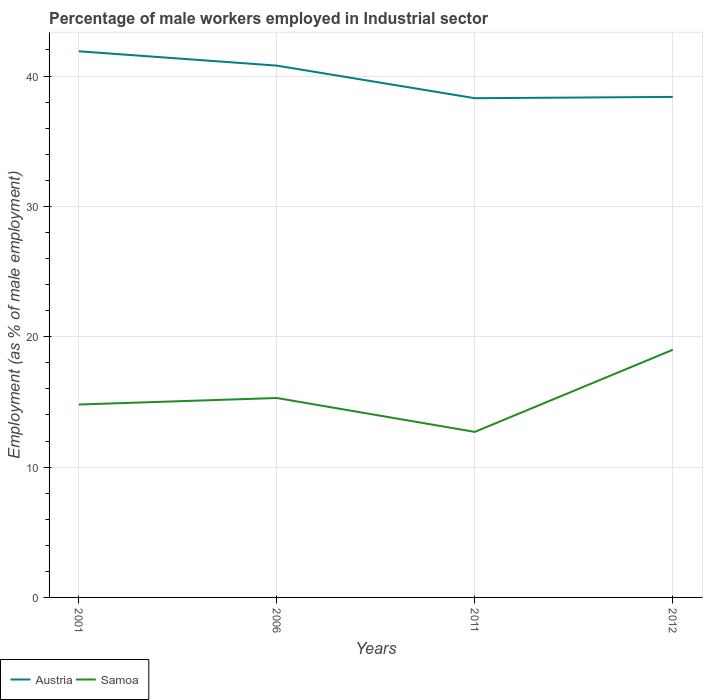Does the line corresponding to Austria intersect with the line corresponding to Samoa?
Give a very brief answer. No. Across all years, what is the maximum percentage of male workers employed in Industrial sector in Austria?
Your answer should be compact. 38.3. What is the total percentage of male workers employed in Industrial sector in Austria in the graph?
Offer a very short reply. 1.1. What is the difference between the highest and the second highest percentage of male workers employed in Industrial sector in Austria?
Make the answer very short. 3.6. What is the difference between the highest and the lowest percentage of male workers employed in Industrial sector in Samoa?
Your answer should be compact. 1. How many years are there in the graph?
Give a very brief answer. 4. What is the difference between two consecutive major ticks on the Y-axis?
Your answer should be compact. 10. Are the values on the major ticks of Y-axis written in scientific E-notation?
Your response must be concise. No. Does the graph contain grids?
Your answer should be compact. Yes. Where does the legend appear in the graph?
Offer a terse response. Bottom left. What is the title of the graph?
Your answer should be very brief. Percentage of male workers employed in Industrial sector. What is the label or title of the Y-axis?
Give a very brief answer. Employment (as % of male employment). What is the Employment (as % of male employment) of Austria in 2001?
Offer a very short reply. 41.9. What is the Employment (as % of male employment) of Samoa in 2001?
Make the answer very short. 14.8. What is the Employment (as % of male employment) of Austria in 2006?
Your answer should be very brief. 40.8. What is the Employment (as % of male employment) of Samoa in 2006?
Keep it short and to the point. 15.3. What is the Employment (as % of male employment) of Austria in 2011?
Your answer should be compact. 38.3. What is the Employment (as % of male employment) of Samoa in 2011?
Keep it short and to the point. 12.7. What is the Employment (as % of male employment) in Austria in 2012?
Ensure brevity in your answer.  38.4. Across all years, what is the maximum Employment (as % of male employment) in Austria?
Your answer should be very brief. 41.9. Across all years, what is the maximum Employment (as % of male employment) of Samoa?
Make the answer very short. 19. Across all years, what is the minimum Employment (as % of male employment) of Austria?
Keep it short and to the point. 38.3. Across all years, what is the minimum Employment (as % of male employment) in Samoa?
Offer a very short reply. 12.7. What is the total Employment (as % of male employment) in Austria in the graph?
Ensure brevity in your answer.  159.4. What is the total Employment (as % of male employment) in Samoa in the graph?
Provide a short and direct response. 61.8. What is the difference between the Employment (as % of male employment) of Austria in 2001 and that in 2006?
Your response must be concise. 1.1. What is the difference between the Employment (as % of male employment) of Samoa in 2001 and that in 2006?
Make the answer very short. -0.5. What is the difference between the Employment (as % of male employment) of Austria in 2001 and that in 2011?
Give a very brief answer. 3.6. What is the difference between the Employment (as % of male employment) in Austria in 2001 and that in 2012?
Provide a short and direct response. 3.5. What is the difference between the Employment (as % of male employment) of Samoa in 2001 and that in 2012?
Offer a terse response. -4.2. What is the difference between the Employment (as % of male employment) in Austria in 2006 and that in 2011?
Keep it short and to the point. 2.5. What is the difference between the Employment (as % of male employment) of Austria in 2006 and that in 2012?
Offer a very short reply. 2.4. What is the difference between the Employment (as % of male employment) in Austria in 2011 and that in 2012?
Offer a terse response. -0.1. What is the difference between the Employment (as % of male employment) in Austria in 2001 and the Employment (as % of male employment) in Samoa in 2006?
Ensure brevity in your answer.  26.6. What is the difference between the Employment (as % of male employment) in Austria in 2001 and the Employment (as % of male employment) in Samoa in 2011?
Your answer should be compact. 29.2. What is the difference between the Employment (as % of male employment) of Austria in 2001 and the Employment (as % of male employment) of Samoa in 2012?
Your answer should be compact. 22.9. What is the difference between the Employment (as % of male employment) of Austria in 2006 and the Employment (as % of male employment) of Samoa in 2011?
Ensure brevity in your answer.  28.1. What is the difference between the Employment (as % of male employment) of Austria in 2006 and the Employment (as % of male employment) of Samoa in 2012?
Provide a succinct answer. 21.8. What is the difference between the Employment (as % of male employment) in Austria in 2011 and the Employment (as % of male employment) in Samoa in 2012?
Offer a very short reply. 19.3. What is the average Employment (as % of male employment) in Austria per year?
Make the answer very short. 39.85. What is the average Employment (as % of male employment) in Samoa per year?
Ensure brevity in your answer.  15.45. In the year 2001, what is the difference between the Employment (as % of male employment) in Austria and Employment (as % of male employment) in Samoa?
Make the answer very short. 27.1. In the year 2006, what is the difference between the Employment (as % of male employment) of Austria and Employment (as % of male employment) of Samoa?
Give a very brief answer. 25.5. In the year 2011, what is the difference between the Employment (as % of male employment) in Austria and Employment (as % of male employment) in Samoa?
Ensure brevity in your answer.  25.6. What is the ratio of the Employment (as % of male employment) in Austria in 2001 to that in 2006?
Your response must be concise. 1.03. What is the ratio of the Employment (as % of male employment) of Samoa in 2001 to that in 2006?
Your answer should be compact. 0.97. What is the ratio of the Employment (as % of male employment) in Austria in 2001 to that in 2011?
Ensure brevity in your answer.  1.09. What is the ratio of the Employment (as % of male employment) in Samoa in 2001 to that in 2011?
Ensure brevity in your answer.  1.17. What is the ratio of the Employment (as % of male employment) in Austria in 2001 to that in 2012?
Your response must be concise. 1.09. What is the ratio of the Employment (as % of male employment) of Samoa in 2001 to that in 2012?
Your answer should be compact. 0.78. What is the ratio of the Employment (as % of male employment) in Austria in 2006 to that in 2011?
Provide a short and direct response. 1.07. What is the ratio of the Employment (as % of male employment) of Samoa in 2006 to that in 2011?
Offer a terse response. 1.2. What is the ratio of the Employment (as % of male employment) of Austria in 2006 to that in 2012?
Your response must be concise. 1.06. What is the ratio of the Employment (as % of male employment) in Samoa in 2006 to that in 2012?
Your answer should be compact. 0.81. What is the ratio of the Employment (as % of male employment) of Samoa in 2011 to that in 2012?
Keep it short and to the point. 0.67. What is the difference between the highest and the second highest Employment (as % of male employment) in Austria?
Provide a short and direct response. 1.1. What is the difference between the highest and the lowest Employment (as % of male employment) of Austria?
Provide a short and direct response. 3.6. 